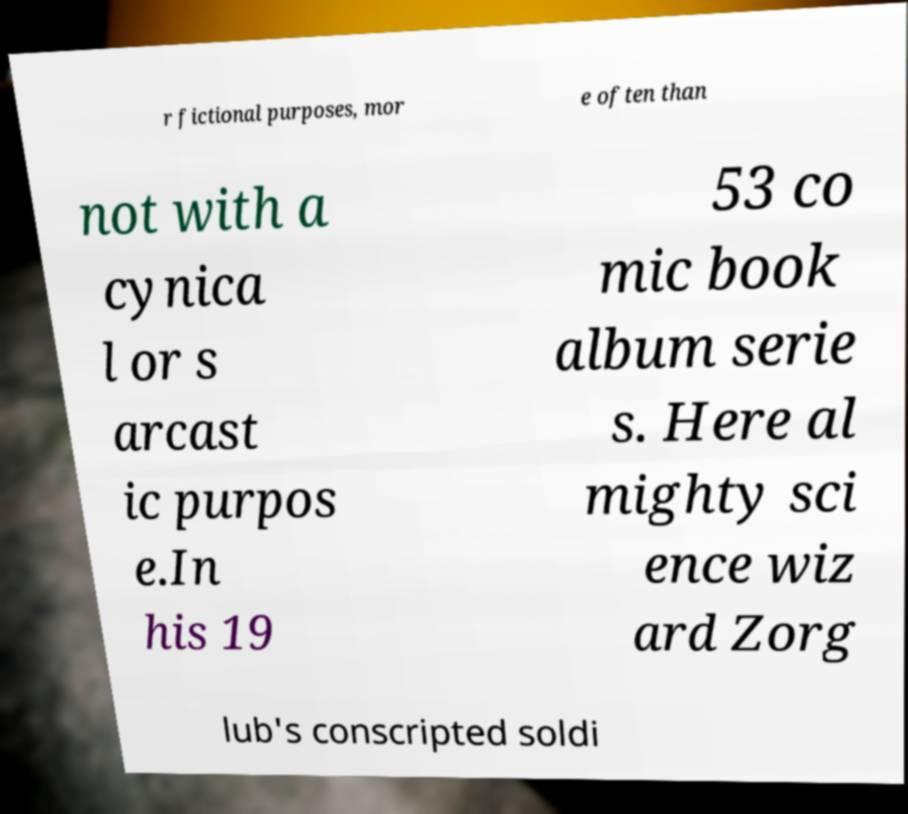For documentation purposes, I need the text within this image transcribed. Could you provide that? r fictional purposes, mor e often than not with a cynica l or s arcast ic purpos e.In his 19 53 co mic book album serie s. Here al mighty sci ence wiz ard Zorg lub's conscripted soldi 